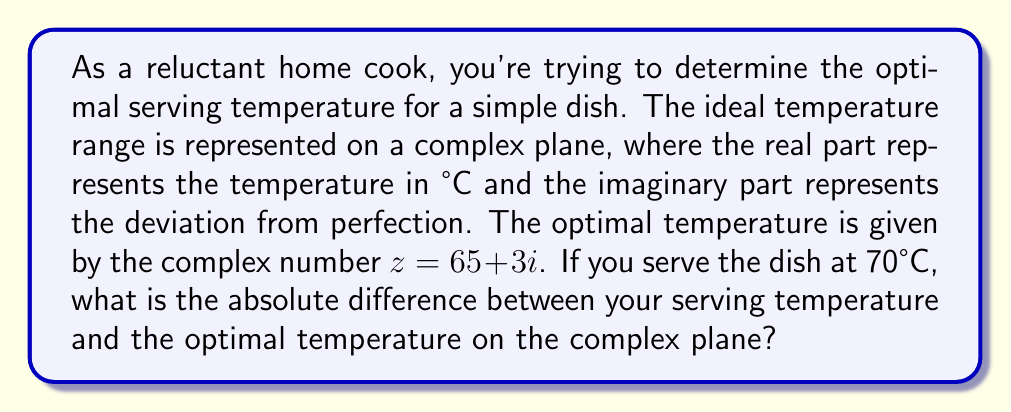Can you solve this math problem? Let's approach this step-by-step:

1) The optimal temperature is represented by $z = 65 + 3i$ on the complex plane.
   - Real part (65) represents the ideal temperature in °C
   - Imaginary part (3i) represents the perfection factor

2) Your actual serving temperature is 70°C, which on the complex plane is represented as $w = 70 + 0i$

3) To find the difference between these two points on the complex plane, we subtract:
   $w - z = (70 + 0i) - (65 + 3i) = 5 - 3i$

4) Now, we need to find the absolute value (or magnitude) of this difference. For a complex number $a + bi$, the absolute value is given by:

   $|a + bi| = \sqrt{a^2 + b^2}$

5) In our case, $a = 5$ and $b = -3$, so:

   $|5 - 3i| = \sqrt{5^2 + (-3)^2} = \sqrt{25 + 9} = \sqrt{34}$

6) $\sqrt{34} \approx 5.83$ (rounded to two decimal places)

This value represents the absolute difference between your serving temperature and the optimal temperature on the complex plane.
Answer: $\sqrt{34}$ or approximately 5.83 